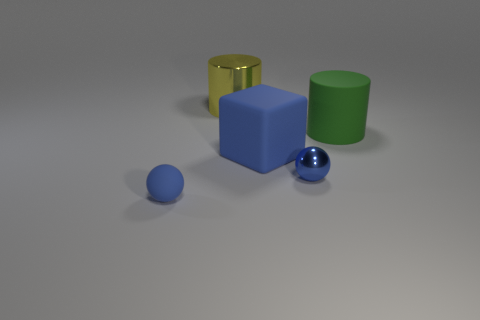There is a small rubber sphere; is its color the same as the ball that is to the right of the yellow metal cylinder?
Give a very brief answer. Yes. There is a cube that is the same color as the tiny rubber ball; what is its material?
Offer a terse response. Rubber. How many blue rubber spheres are there?
Offer a terse response. 1. Is the number of big cubes less than the number of large yellow matte cylinders?
Offer a very short reply. No. There is a yellow thing that is the same size as the blue cube; what material is it?
Your answer should be very brief. Metal. How many objects are large yellow metal cylinders or blue shiny balls?
Make the answer very short. 2. How many blue things are both in front of the blue cube and right of the yellow cylinder?
Offer a terse response. 1. Are there fewer large green cylinders left of the shiny sphere than small blue spheres?
Offer a terse response. Yes. There is a blue rubber thing that is the same size as the yellow cylinder; what shape is it?
Offer a terse response. Cube. What number of other objects are the same color as the big metallic thing?
Your answer should be very brief. 0. 